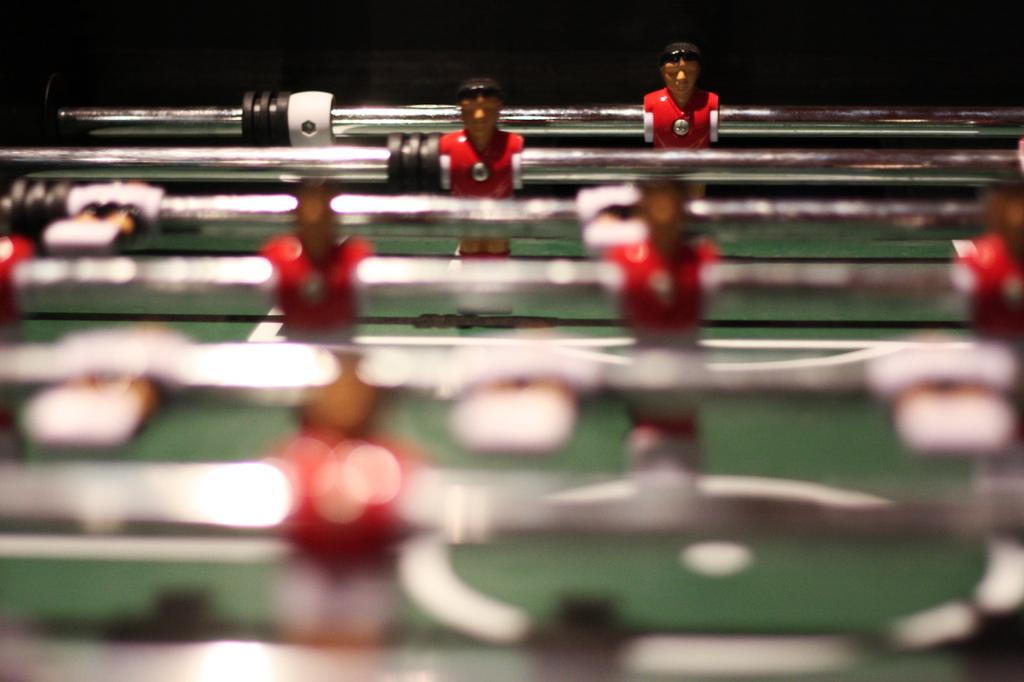What type of game is featured in the image? There is a table football game in the image. Can you describe the game in more detail? The game involves players controlling small figures on a table, using handles to move them and try to score goals. What might be the purpose of this game? The purpose of the game is likely to provide entertainment and competition for the players. What type of tray is used to serve the roll in the image? There is no tray or roll present in the image; it features a table football game. 